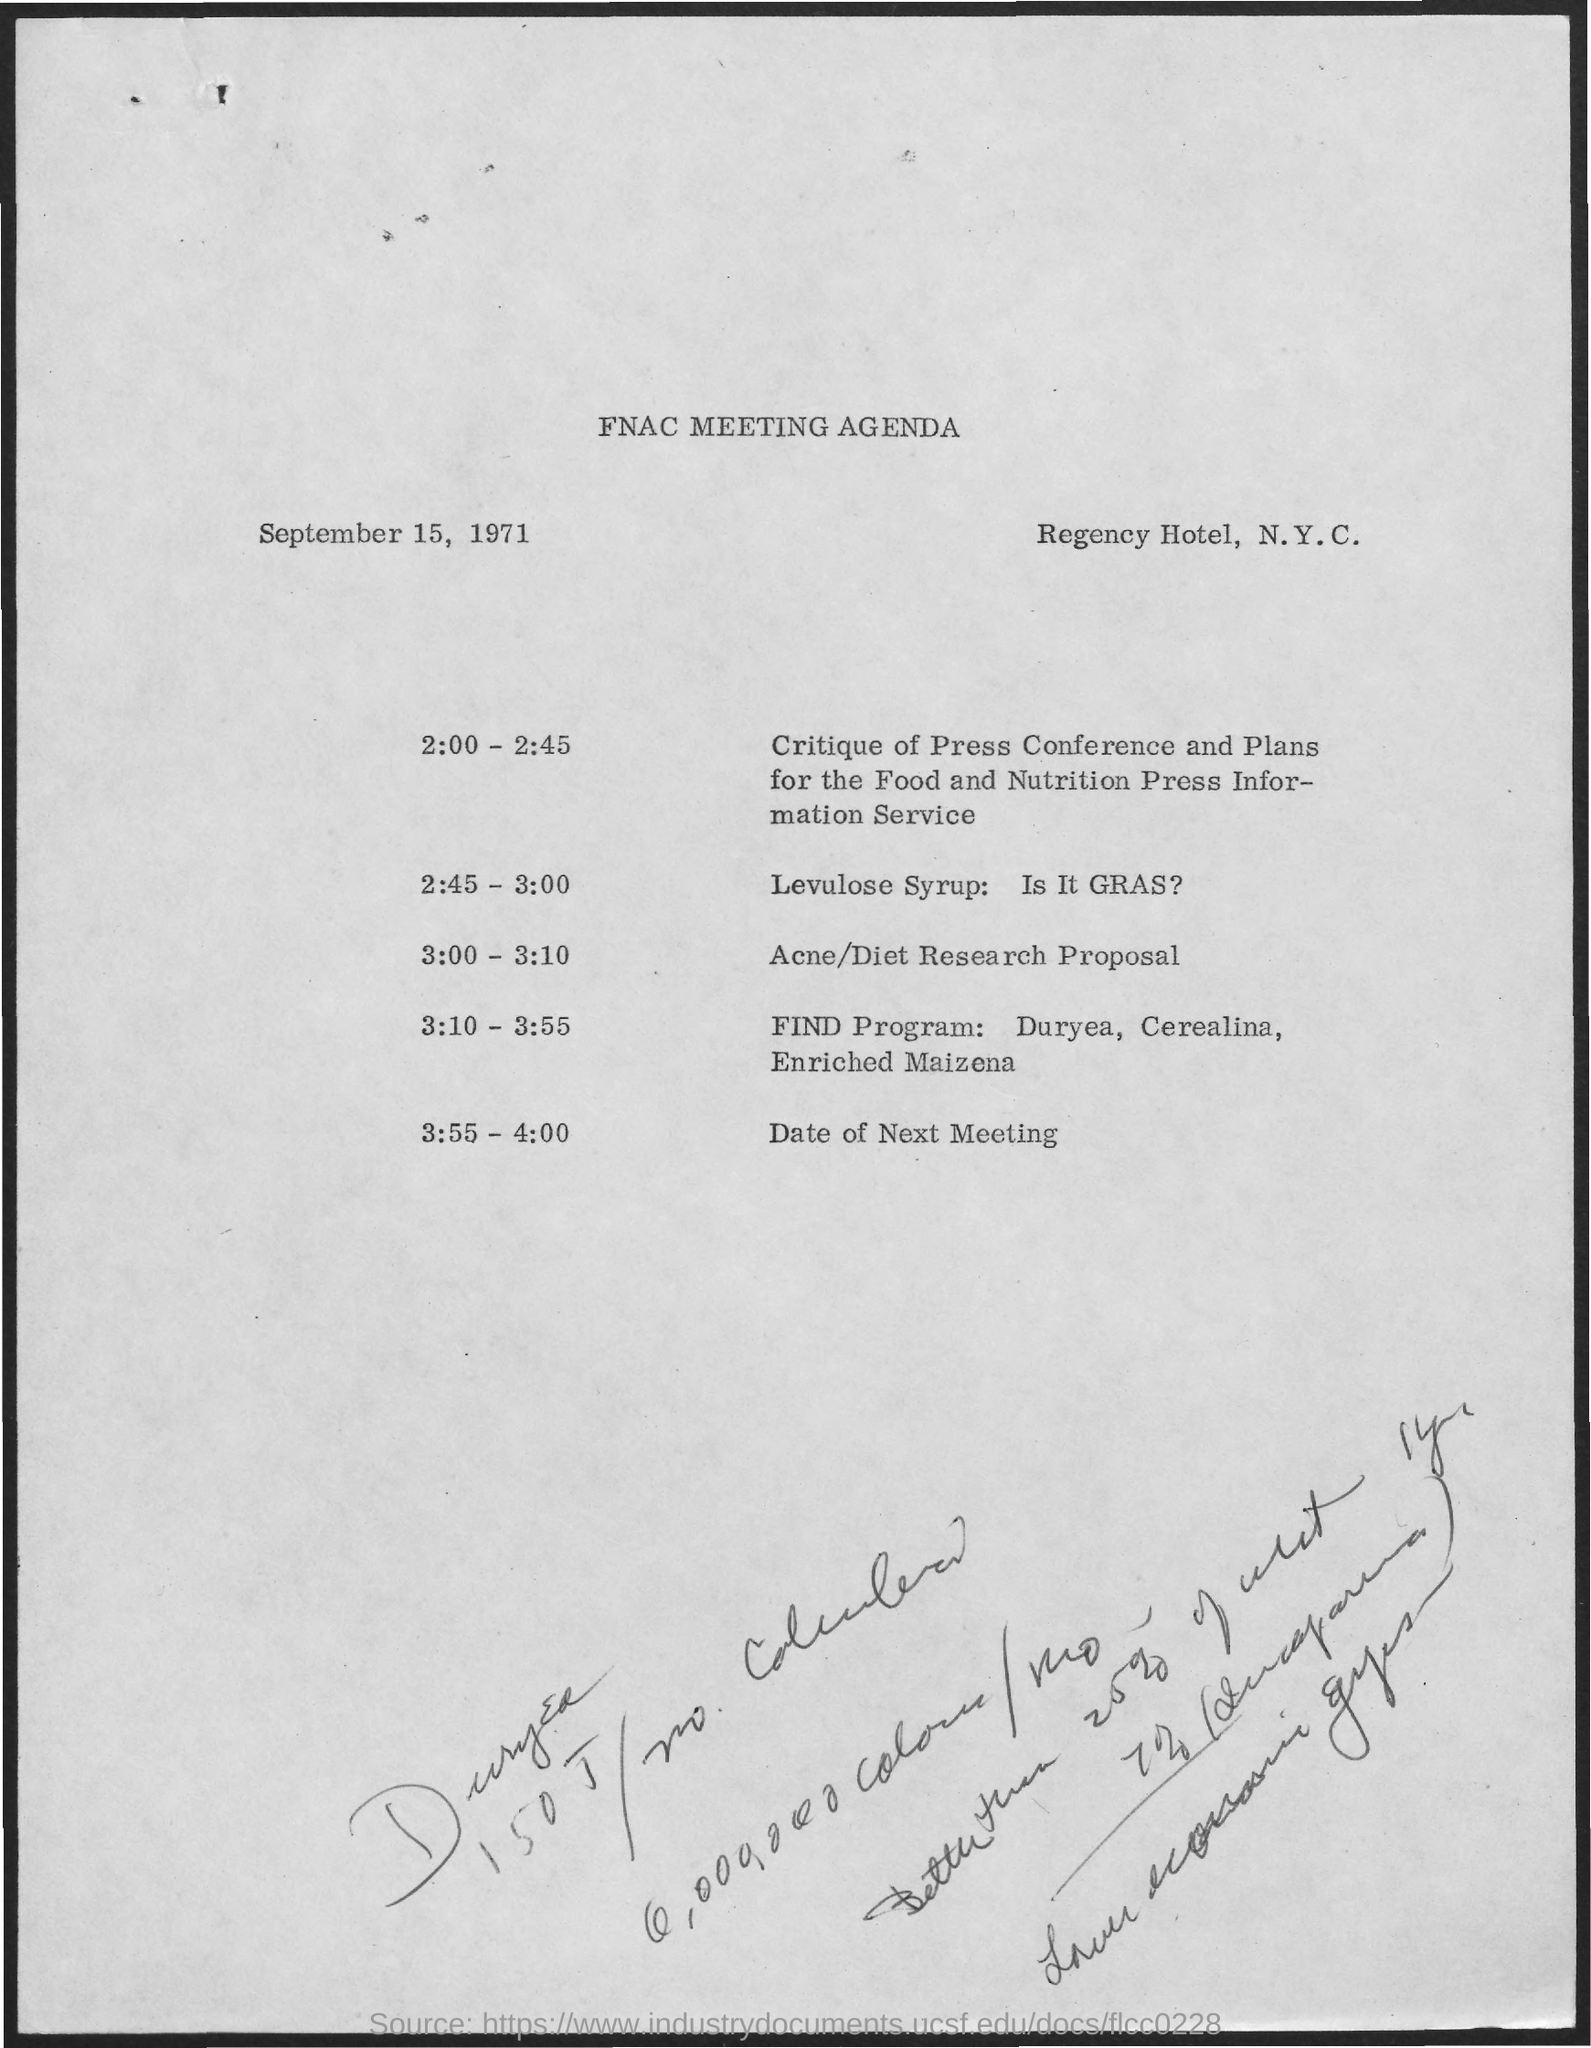Where is  FNAC meeting  planned?
Offer a very short reply. Regency Hotel, N.Y.C. What was discussed at 2.00-2:45?
Offer a very short reply. Critique of Press Conference and Plans for the Food and Nutrition press Information Service. What's the time when Acne/Diet Research proposal is discussed?
Provide a succinct answer. 3:00 - 3:10. When was meeting held?
Offer a very short reply. September 15, 1971. What was discussed before the proposal?
Ensure brevity in your answer.  Levulose syrup: Is It GRAS?. What was the final discussion in meeting?
Your response must be concise. Date of next meeting. 